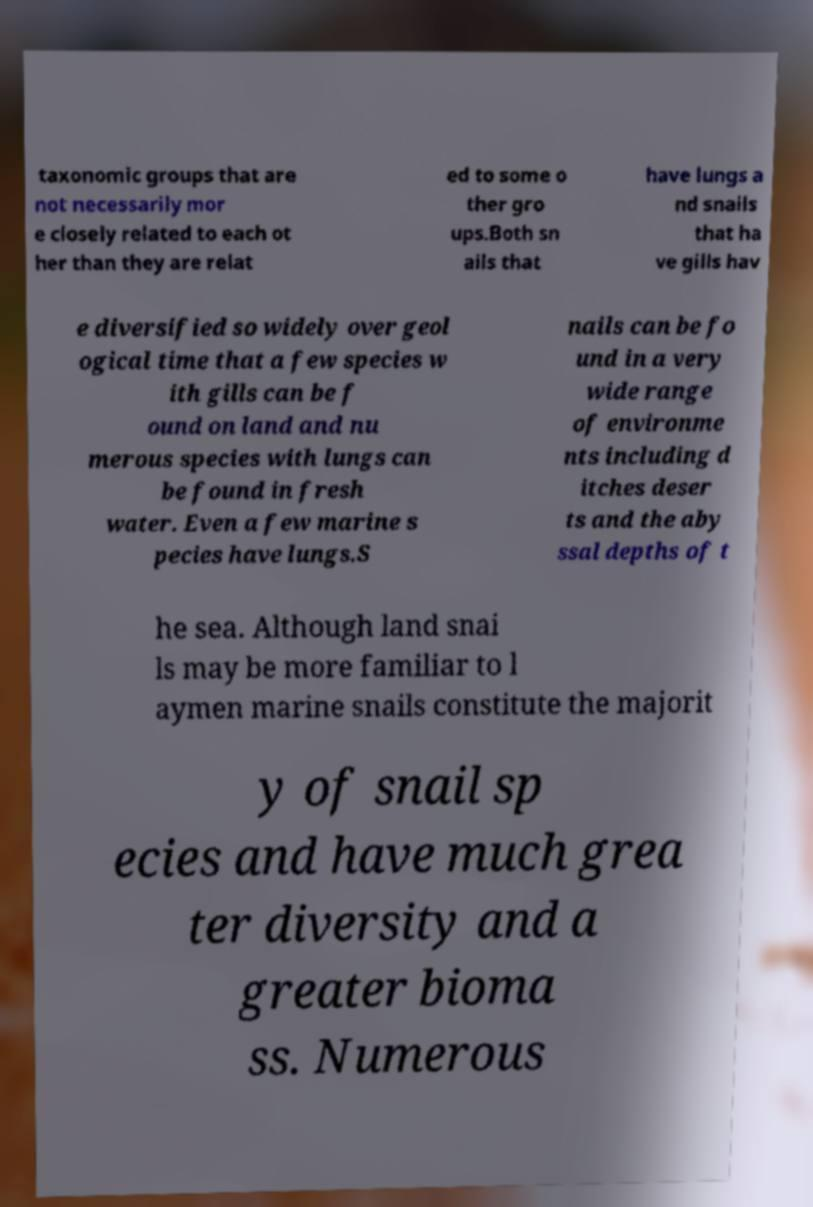Please identify and transcribe the text found in this image. taxonomic groups that are not necessarily mor e closely related to each ot her than they are relat ed to some o ther gro ups.Both sn ails that have lungs a nd snails that ha ve gills hav e diversified so widely over geol ogical time that a few species w ith gills can be f ound on land and nu merous species with lungs can be found in fresh water. Even a few marine s pecies have lungs.S nails can be fo und in a very wide range of environme nts including d itches deser ts and the aby ssal depths of t he sea. Although land snai ls may be more familiar to l aymen marine snails constitute the majorit y of snail sp ecies and have much grea ter diversity and a greater bioma ss. Numerous 